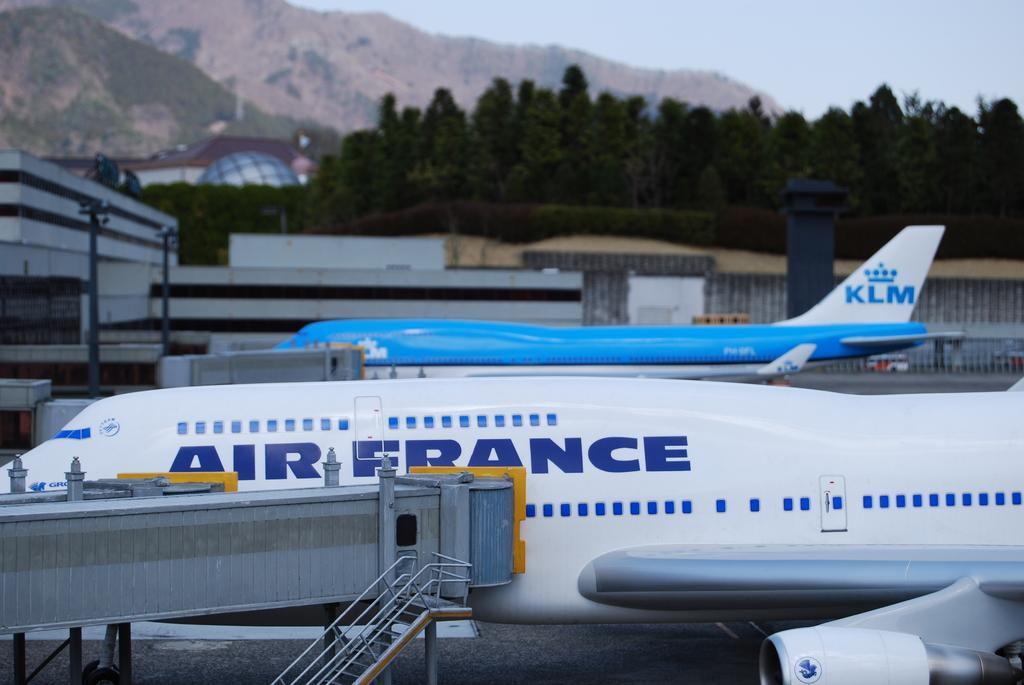<image>
Relay a brief, clear account of the picture shown. AirFrance airplane is parked in the airport with a KLM airplane. 